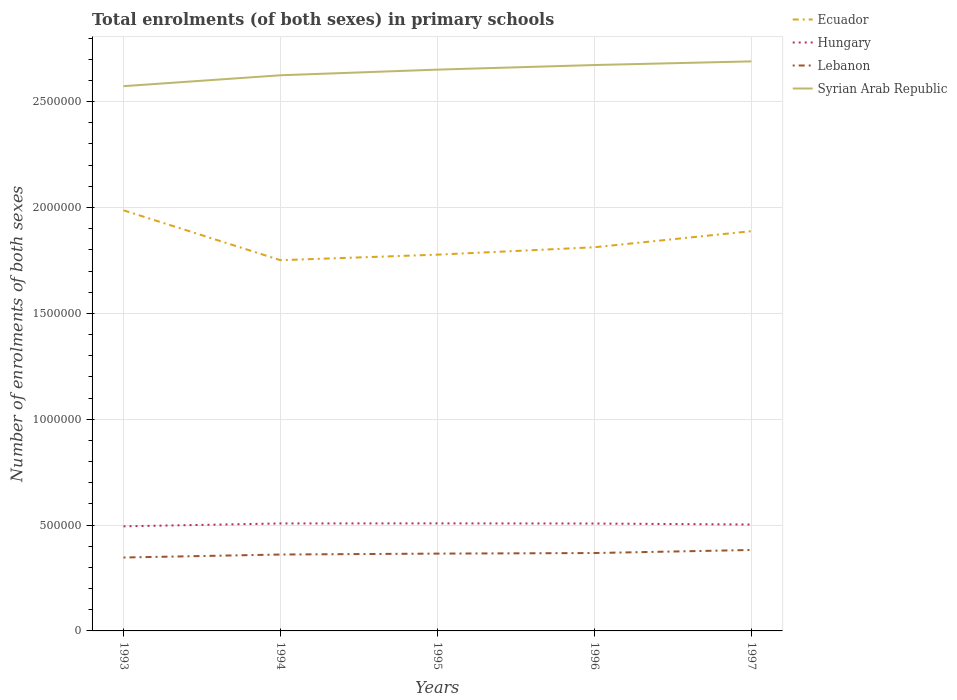How many different coloured lines are there?
Ensure brevity in your answer.  4. Across all years, what is the maximum number of enrolments in primary schools in Lebanon?
Provide a short and direct response. 3.47e+05. What is the total number of enrolments in primary schools in Lebanon in the graph?
Offer a very short reply. -1.41e+04. What is the difference between the highest and the second highest number of enrolments in primary schools in Syrian Arab Republic?
Offer a very short reply. 1.17e+05. How many lines are there?
Provide a short and direct response. 4. How many years are there in the graph?
Ensure brevity in your answer.  5. What is the difference between two consecutive major ticks on the Y-axis?
Your response must be concise. 5.00e+05. Are the values on the major ticks of Y-axis written in scientific E-notation?
Provide a short and direct response. No. Does the graph contain any zero values?
Ensure brevity in your answer.  No. Where does the legend appear in the graph?
Offer a very short reply. Top right. What is the title of the graph?
Provide a succinct answer. Total enrolments (of both sexes) in primary schools. What is the label or title of the Y-axis?
Keep it short and to the point. Number of enrolments of both sexes. What is the Number of enrolments of both sexes in Ecuador in 1993?
Your answer should be very brief. 1.99e+06. What is the Number of enrolments of both sexes in Hungary in 1993?
Your answer should be very brief. 4.94e+05. What is the Number of enrolments of both sexes in Lebanon in 1993?
Make the answer very short. 3.47e+05. What is the Number of enrolments of both sexes in Syrian Arab Republic in 1993?
Offer a very short reply. 2.57e+06. What is the Number of enrolments of both sexes in Ecuador in 1994?
Make the answer very short. 1.75e+06. What is the Number of enrolments of both sexes in Hungary in 1994?
Offer a very short reply. 5.08e+05. What is the Number of enrolments of both sexes in Lebanon in 1994?
Offer a terse response. 3.61e+05. What is the Number of enrolments of both sexes in Syrian Arab Republic in 1994?
Your answer should be compact. 2.62e+06. What is the Number of enrolments of both sexes in Ecuador in 1995?
Your response must be concise. 1.78e+06. What is the Number of enrolments of both sexes of Hungary in 1995?
Make the answer very short. 5.08e+05. What is the Number of enrolments of both sexes of Lebanon in 1995?
Keep it short and to the point. 3.65e+05. What is the Number of enrolments of both sexes of Syrian Arab Republic in 1995?
Offer a terse response. 2.65e+06. What is the Number of enrolments of both sexes of Ecuador in 1996?
Keep it short and to the point. 1.81e+06. What is the Number of enrolments of both sexes in Hungary in 1996?
Your answer should be compact. 5.07e+05. What is the Number of enrolments of both sexes in Lebanon in 1996?
Your response must be concise. 3.68e+05. What is the Number of enrolments of both sexes in Syrian Arab Republic in 1996?
Offer a terse response. 2.67e+06. What is the Number of enrolments of both sexes in Ecuador in 1997?
Offer a very short reply. 1.89e+06. What is the Number of enrolments of both sexes in Hungary in 1997?
Ensure brevity in your answer.  5.03e+05. What is the Number of enrolments of both sexes in Lebanon in 1997?
Keep it short and to the point. 3.82e+05. What is the Number of enrolments of both sexes in Syrian Arab Republic in 1997?
Ensure brevity in your answer.  2.69e+06. Across all years, what is the maximum Number of enrolments of both sexes in Ecuador?
Offer a very short reply. 1.99e+06. Across all years, what is the maximum Number of enrolments of both sexes in Hungary?
Offer a terse response. 5.08e+05. Across all years, what is the maximum Number of enrolments of both sexes of Lebanon?
Your response must be concise. 3.82e+05. Across all years, what is the maximum Number of enrolments of both sexes of Syrian Arab Republic?
Offer a very short reply. 2.69e+06. Across all years, what is the minimum Number of enrolments of both sexes of Ecuador?
Your answer should be very brief. 1.75e+06. Across all years, what is the minimum Number of enrolments of both sexes in Hungary?
Your response must be concise. 4.94e+05. Across all years, what is the minimum Number of enrolments of both sexes in Lebanon?
Your answer should be compact. 3.47e+05. Across all years, what is the minimum Number of enrolments of both sexes in Syrian Arab Republic?
Provide a succinct answer. 2.57e+06. What is the total Number of enrolments of both sexes of Ecuador in the graph?
Keep it short and to the point. 9.22e+06. What is the total Number of enrolments of both sexes of Hungary in the graph?
Give a very brief answer. 2.52e+06. What is the total Number of enrolments of both sexes of Lebanon in the graph?
Provide a short and direct response. 1.82e+06. What is the total Number of enrolments of both sexes in Syrian Arab Republic in the graph?
Make the answer very short. 1.32e+07. What is the difference between the Number of enrolments of both sexes of Ecuador in 1993 and that in 1994?
Make the answer very short. 2.36e+05. What is the difference between the Number of enrolments of both sexes of Hungary in 1993 and that in 1994?
Provide a succinct answer. -1.35e+04. What is the difference between the Number of enrolments of both sexes of Lebanon in 1993 and that in 1994?
Ensure brevity in your answer.  -1.41e+04. What is the difference between the Number of enrolments of both sexes in Syrian Arab Republic in 1993 and that in 1994?
Offer a terse response. -5.14e+04. What is the difference between the Number of enrolments of both sexes in Ecuador in 1993 and that in 1995?
Offer a very short reply. 2.09e+05. What is the difference between the Number of enrolments of both sexes of Hungary in 1993 and that in 1995?
Your answer should be very brief. -1.39e+04. What is the difference between the Number of enrolments of both sexes of Lebanon in 1993 and that in 1995?
Offer a terse response. -1.84e+04. What is the difference between the Number of enrolments of both sexes of Syrian Arab Republic in 1993 and that in 1995?
Provide a succinct answer. -7.81e+04. What is the difference between the Number of enrolments of both sexes of Ecuador in 1993 and that in 1996?
Provide a succinct answer. 1.74e+05. What is the difference between the Number of enrolments of both sexes of Hungary in 1993 and that in 1996?
Keep it short and to the point. -1.31e+04. What is the difference between the Number of enrolments of both sexes of Lebanon in 1993 and that in 1996?
Keep it short and to the point. -2.11e+04. What is the difference between the Number of enrolments of both sexes in Syrian Arab Republic in 1993 and that in 1996?
Make the answer very short. -9.98e+04. What is the difference between the Number of enrolments of both sexes in Ecuador in 1993 and that in 1997?
Keep it short and to the point. 9.86e+04. What is the difference between the Number of enrolments of both sexes in Hungary in 1993 and that in 1997?
Provide a succinct answer. -8448. What is the difference between the Number of enrolments of both sexes of Lebanon in 1993 and that in 1997?
Give a very brief answer. -3.55e+04. What is the difference between the Number of enrolments of both sexes in Syrian Arab Republic in 1993 and that in 1997?
Make the answer very short. -1.17e+05. What is the difference between the Number of enrolments of both sexes of Ecuador in 1994 and that in 1995?
Give a very brief answer. -2.62e+04. What is the difference between the Number of enrolments of both sexes in Hungary in 1994 and that in 1995?
Provide a succinct answer. -386. What is the difference between the Number of enrolments of both sexes in Lebanon in 1994 and that in 1995?
Make the answer very short. -4316. What is the difference between the Number of enrolments of both sexes of Syrian Arab Republic in 1994 and that in 1995?
Give a very brief answer. -2.67e+04. What is the difference between the Number of enrolments of both sexes of Ecuador in 1994 and that in 1996?
Your answer should be very brief. -6.11e+04. What is the difference between the Number of enrolments of both sexes in Hungary in 1994 and that in 1996?
Your response must be concise. 379. What is the difference between the Number of enrolments of both sexes in Lebanon in 1994 and that in 1996?
Offer a very short reply. -7004. What is the difference between the Number of enrolments of both sexes of Syrian Arab Republic in 1994 and that in 1996?
Ensure brevity in your answer.  -4.84e+04. What is the difference between the Number of enrolments of both sexes in Ecuador in 1994 and that in 1997?
Offer a very short reply. -1.37e+05. What is the difference between the Number of enrolments of both sexes in Hungary in 1994 and that in 1997?
Keep it short and to the point. 5062. What is the difference between the Number of enrolments of both sexes of Lebanon in 1994 and that in 1997?
Give a very brief answer. -2.15e+04. What is the difference between the Number of enrolments of both sexes of Syrian Arab Republic in 1994 and that in 1997?
Offer a terse response. -6.56e+04. What is the difference between the Number of enrolments of both sexes of Ecuador in 1995 and that in 1996?
Offer a very short reply. -3.50e+04. What is the difference between the Number of enrolments of both sexes in Hungary in 1995 and that in 1996?
Your response must be concise. 765. What is the difference between the Number of enrolments of both sexes in Lebanon in 1995 and that in 1996?
Offer a terse response. -2688. What is the difference between the Number of enrolments of both sexes of Syrian Arab Republic in 1995 and that in 1996?
Offer a terse response. -2.17e+04. What is the difference between the Number of enrolments of both sexes in Ecuador in 1995 and that in 1997?
Make the answer very short. -1.11e+05. What is the difference between the Number of enrolments of both sexes of Hungary in 1995 and that in 1997?
Your answer should be very brief. 5448. What is the difference between the Number of enrolments of both sexes in Lebanon in 1995 and that in 1997?
Make the answer very short. -1.71e+04. What is the difference between the Number of enrolments of both sexes in Syrian Arab Republic in 1995 and that in 1997?
Keep it short and to the point. -3.90e+04. What is the difference between the Number of enrolments of both sexes in Ecuador in 1996 and that in 1997?
Provide a succinct answer. -7.59e+04. What is the difference between the Number of enrolments of both sexes of Hungary in 1996 and that in 1997?
Ensure brevity in your answer.  4683. What is the difference between the Number of enrolments of both sexes of Lebanon in 1996 and that in 1997?
Offer a very short reply. -1.44e+04. What is the difference between the Number of enrolments of both sexes of Syrian Arab Republic in 1996 and that in 1997?
Your answer should be very brief. -1.72e+04. What is the difference between the Number of enrolments of both sexes of Ecuador in 1993 and the Number of enrolments of both sexes of Hungary in 1994?
Keep it short and to the point. 1.48e+06. What is the difference between the Number of enrolments of both sexes in Ecuador in 1993 and the Number of enrolments of both sexes in Lebanon in 1994?
Give a very brief answer. 1.63e+06. What is the difference between the Number of enrolments of both sexes of Ecuador in 1993 and the Number of enrolments of both sexes of Syrian Arab Republic in 1994?
Provide a succinct answer. -6.38e+05. What is the difference between the Number of enrolments of both sexes in Hungary in 1993 and the Number of enrolments of both sexes in Lebanon in 1994?
Your response must be concise. 1.33e+05. What is the difference between the Number of enrolments of both sexes of Hungary in 1993 and the Number of enrolments of both sexes of Syrian Arab Republic in 1994?
Provide a short and direct response. -2.13e+06. What is the difference between the Number of enrolments of both sexes in Lebanon in 1993 and the Number of enrolments of both sexes in Syrian Arab Republic in 1994?
Your answer should be very brief. -2.28e+06. What is the difference between the Number of enrolments of both sexes of Ecuador in 1993 and the Number of enrolments of both sexes of Hungary in 1995?
Offer a very short reply. 1.48e+06. What is the difference between the Number of enrolments of both sexes of Ecuador in 1993 and the Number of enrolments of both sexes of Lebanon in 1995?
Offer a very short reply. 1.62e+06. What is the difference between the Number of enrolments of both sexes of Ecuador in 1993 and the Number of enrolments of both sexes of Syrian Arab Republic in 1995?
Your response must be concise. -6.64e+05. What is the difference between the Number of enrolments of both sexes of Hungary in 1993 and the Number of enrolments of both sexes of Lebanon in 1995?
Provide a short and direct response. 1.29e+05. What is the difference between the Number of enrolments of both sexes of Hungary in 1993 and the Number of enrolments of both sexes of Syrian Arab Republic in 1995?
Your answer should be compact. -2.16e+06. What is the difference between the Number of enrolments of both sexes in Lebanon in 1993 and the Number of enrolments of both sexes in Syrian Arab Republic in 1995?
Give a very brief answer. -2.30e+06. What is the difference between the Number of enrolments of both sexes of Ecuador in 1993 and the Number of enrolments of both sexes of Hungary in 1996?
Make the answer very short. 1.48e+06. What is the difference between the Number of enrolments of both sexes of Ecuador in 1993 and the Number of enrolments of both sexes of Lebanon in 1996?
Provide a short and direct response. 1.62e+06. What is the difference between the Number of enrolments of both sexes of Ecuador in 1993 and the Number of enrolments of both sexes of Syrian Arab Republic in 1996?
Your answer should be compact. -6.86e+05. What is the difference between the Number of enrolments of both sexes in Hungary in 1993 and the Number of enrolments of both sexes in Lebanon in 1996?
Provide a succinct answer. 1.26e+05. What is the difference between the Number of enrolments of both sexes of Hungary in 1993 and the Number of enrolments of both sexes of Syrian Arab Republic in 1996?
Offer a terse response. -2.18e+06. What is the difference between the Number of enrolments of both sexes in Lebanon in 1993 and the Number of enrolments of both sexes in Syrian Arab Republic in 1996?
Your response must be concise. -2.33e+06. What is the difference between the Number of enrolments of both sexes in Ecuador in 1993 and the Number of enrolments of both sexes in Hungary in 1997?
Give a very brief answer. 1.48e+06. What is the difference between the Number of enrolments of both sexes of Ecuador in 1993 and the Number of enrolments of both sexes of Lebanon in 1997?
Provide a short and direct response. 1.60e+06. What is the difference between the Number of enrolments of both sexes of Ecuador in 1993 and the Number of enrolments of both sexes of Syrian Arab Republic in 1997?
Make the answer very short. -7.03e+05. What is the difference between the Number of enrolments of both sexes of Hungary in 1993 and the Number of enrolments of both sexes of Lebanon in 1997?
Offer a very short reply. 1.12e+05. What is the difference between the Number of enrolments of both sexes of Hungary in 1993 and the Number of enrolments of both sexes of Syrian Arab Republic in 1997?
Your response must be concise. -2.20e+06. What is the difference between the Number of enrolments of both sexes in Lebanon in 1993 and the Number of enrolments of both sexes in Syrian Arab Republic in 1997?
Your response must be concise. -2.34e+06. What is the difference between the Number of enrolments of both sexes in Ecuador in 1994 and the Number of enrolments of both sexes in Hungary in 1995?
Provide a succinct answer. 1.24e+06. What is the difference between the Number of enrolments of both sexes in Ecuador in 1994 and the Number of enrolments of both sexes in Lebanon in 1995?
Your answer should be very brief. 1.39e+06. What is the difference between the Number of enrolments of both sexes of Ecuador in 1994 and the Number of enrolments of both sexes of Syrian Arab Republic in 1995?
Make the answer very short. -9.00e+05. What is the difference between the Number of enrolments of both sexes of Hungary in 1994 and the Number of enrolments of both sexes of Lebanon in 1995?
Your answer should be compact. 1.42e+05. What is the difference between the Number of enrolments of both sexes of Hungary in 1994 and the Number of enrolments of both sexes of Syrian Arab Republic in 1995?
Offer a very short reply. -2.14e+06. What is the difference between the Number of enrolments of both sexes in Lebanon in 1994 and the Number of enrolments of both sexes in Syrian Arab Republic in 1995?
Offer a very short reply. -2.29e+06. What is the difference between the Number of enrolments of both sexes in Ecuador in 1994 and the Number of enrolments of both sexes in Hungary in 1996?
Offer a very short reply. 1.24e+06. What is the difference between the Number of enrolments of both sexes in Ecuador in 1994 and the Number of enrolments of both sexes in Lebanon in 1996?
Make the answer very short. 1.38e+06. What is the difference between the Number of enrolments of both sexes of Ecuador in 1994 and the Number of enrolments of both sexes of Syrian Arab Republic in 1996?
Your answer should be compact. -9.22e+05. What is the difference between the Number of enrolments of both sexes of Hungary in 1994 and the Number of enrolments of both sexes of Lebanon in 1996?
Your answer should be very brief. 1.40e+05. What is the difference between the Number of enrolments of both sexes in Hungary in 1994 and the Number of enrolments of both sexes in Syrian Arab Republic in 1996?
Provide a succinct answer. -2.17e+06. What is the difference between the Number of enrolments of both sexes in Lebanon in 1994 and the Number of enrolments of both sexes in Syrian Arab Republic in 1996?
Your response must be concise. -2.31e+06. What is the difference between the Number of enrolments of both sexes of Ecuador in 1994 and the Number of enrolments of both sexes of Hungary in 1997?
Provide a short and direct response. 1.25e+06. What is the difference between the Number of enrolments of both sexes in Ecuador in 1994 and the Number of enrolments of both sexes in Lebanon in 1997?
Your answer should be very brief. 1.37e+06. What is the difference between the Number of enrolments of both sexes of Ecuador in 1994 and the Number of enrolments of both sexes of Syrian Arab Republic in 1997?
Your answer should be compact. -9.39e+05. What is the difference between the Number of enrolments of both sexes in Hungary in 1994 and the Number of enrolments of both sexes in Lebanon in 1997?
Keep it short and to the point. 1.25e+05. What is the difference between the Number of enrolments of both sexes in Hungary in 1994 and the Number of enrolments of both sexes in Syrian Arab Republic in 1997?
Ensure brevity in your answer.  -2.18e+06. What is the difference between the Number of enrolments of both sexes of Lebanon in 1994 and the Number of enrolments of both sexes of Syrian Arab Republic in 1997?
Give a very brief answer. -2.33e+06. What is the difference between the Number of enrolments of both sexes in Ecuador in 1995 and the Number of enrolments of both sexes in Hungary in 1996?
Your response must be concise. 1.27e+06. What is the difference between the Number of enrolments of both sexes of Ecuador in 1995 and the Number of enrolments of both sexes of Lebanon in 1996?
Offer a terse response. 1.41e+06. What is the difference between the Number of enrolments of both sexes of Ecuador in 1995 and the Number of enrolments of both sexes of Syrian Arab Republic in 1996?
Your answer should be compact. -8.96e+05. What is the difference between the Number of enrolments of both sexes of Hungary in 1995 and the Number of enrolments of both sexes of Lebanon in 1996?
Offer a terse response. 1.40e+05. What is the difference between the Number of enrolments of both sexes of Hungary in 1995 and the Number of enrolments of both sexes of Syrian Arab Republic in 1996?
Your response must be concise. -2.16e+06. What is the difference between the Number of enrolments of both sexes of Lebanon in 1995 and the Number of enrolments of both sexes of Syrian Arab Republic in 1996?
Provide a short and direct response. -2.31e+06. What is the difference between the Number of enrolments of both sexes of Ecuador in 1995 and the Number of enrolments of both sexes of Hungary in 1997?
Provide a short and direct response. 1.27e+06. What is the difference between the Number of enrolments of both sexes in Ecuador in 1995 and the Number of enrolments of both sexes in Lebanon in 1997?
Give a very brief answer. 1.39e+06. What is the difference between the Number of enrolments of both sexes of Ecuador in 1995 and the Number of enrolments of both sexes of Syrian Arab Republic in 1997?
Give a very brief answer. -9.13e+05. What is the difference between the Number of enrolments of both sexes in Hungary in 1995 and the Number of enrolments of both sexes in Lebanon in 1997?
Your response must be concise. 1.26e+05. What is the difference between the Number of enrolments of both sexes of Hungary in 1995 and the Number of enrolments of both sexes of Syrian Arab Republic in 1997?
Provide a succinct answer. -2.18e+06. What is the difference between the Number of enrolments of both sexes of Lebanon in 1995 and the Number of enrolments of both sexes of Syrian Arab Republic in 1997?
Provide a succinct answer. -2.33e+06. What is the difference between the Number of enrolments of both sexes of Ecuador in 1996 and the Number of enrolments of both sexes of Hungary in 1997?
Your answer should be very brief. 1.31e+06. What is the difference between the Number of enrolments of both sexes of Ecuador in 1996 and the Number of enrolments of both sexes of Lebanon in 1997?
Make the answer very short. 1.43e+06. What is the difference between the Number of enrolments of both sexes of Ecuador in 1996 and the Number of enrolments of both sexes of Syrian Arab Republic in 1997?
Your answer should be compact. -8.78e+05. What is the difference between the Number of enrolments of both sexes in Hungary in 1996 and the Number of enrolments of both sexes in Lebanon in 1997?
Keep it short and to the point. 1.25e+05. What is the difference between the Number of enrolments of both sexes in Hungary in 1996 and the Number of enrolments of both sexes in Syrian Arab Republic in 1997?
Give a very brief answer. -2.18e+06. What is the difference between the Number of enrolments of both sexes of Lebanon in 1996 and the Number of enrolments of both sexes of Syrian Arab Republic in 1997?
Your answer should be compact. -2.32e+06. What is the average Number of enrolments of both sexes in Ecuador per year?
Provide a succinct answer. 1.84e+06. What is the average Number of enrolments of both sexes in Hungary per year?
Your answer should be very brief. 5.04e+05. What is the average Number of enrolments of both sexes in Lebanon per year?
Keep it short and to the point. 3.65e+05. What is the average Number of enrolments of both sexes of Syrian Arab Republic per year?
Your answer should be compact. 2.64e+06. In the year 1993, what is the difference between the Number of enrolments of both sexes in Ecuador and Number of enrolments of both sexes in Hungary?
Keep it short and to the point. 1.49e+06. In the year 1993, what is the difference between the Number of enrolments of both sexes of Ecuador and Number of enrolments of both sexes of Lebanon?
Provide a succinct answer. 1.64e+06. In the year 1993, what is the difference between the Number of enrolments of both sexes of Ecuador and Number of enrolments of both sexes of Syrian Arab Republic?
Make the answer very short. -5.86e+05. In the year 1993, what is the difference between the Number of enrolments of both sexes of Hungary and Number of enrolments of both sexes of Lebanon?
Your answer should be very brief. 1.47e+05. In the year 1993, what is the difference between the Number of enrolments of both sexes of Hungary and Number of enrolments of both sexes of Syrian Arab Republic?
Provide a short and direct response. -2.08e+06. In the year 1993, what is the difference between the Number of enrolments of both sexes in Lebanon and Number of enrolments of both sexes in Syrian Arab Republic?
Offer a very short reply. -2.23e+06. In the year 1994, what is the difference between the Number of enrolments of both sexes of Ecuador and Number of enrolments of both sexes of Hungary?
Provide a succinct answer. 1.24e+06. In the year 1994, what is the difference between the Number of enrolments of both sexes of Ecuador and Number of enrolments of both sexes of Lebanon?
Your answer should be compact. 1.39e+06. In the year 1994, what is the difference between the Number of enrolments of both sexes of Ecuador and Number of enrolments of both sexes of Syrian Arab Republic?
Make the answer very short. -8.73e+05. In the year 1994, what is the difference between the Number of enrolments of both sexes in Hungary and Number of enrolments of both sexes in Lebanon?
Your answer should be compact. 1.47e+05. In the year 1994, what is the difference between the Number of enrolments of both sexes in Hungary and Number of enrolments of both sexes in Syrian Arab Republic?
Provide a short and direct response. -2.12e+06. In the year 1994, what is the difference between the Number of enrolments of both sexes of Lebanon and Number of enrolments of both sexes of Syrian Arab Republic?
Provide a short and direct response. -2.26e+06. In the year 1995, what is the difference between the Number of enrolments of both sexes of Ecuador and Number of enrolments of both sexes of Hungary?
Your response must be concise. 1.27e+06. In the year 1995, what is the difference between the Number of enrolments of both sexes in Ecuador and Number of enrolments of both sexes in Lebanon?
Keep it short and to the point. 1.41e+06. In the year 1995, what is the difference between the Number of enrolments of both sexes of Ecuador and Number of enrolments of both sexes of Syrian Arab Republic?
Provide a short and direct response. -8.74e+05. In the year 1995, what is the difference between the Number of enrolments of both sexes in Hungary and Number of enrolments of both sexes in Lebanon?
Your answer should be very brief. 1.43e+05. In the year 1995, what is the difference between the Number of enrolments of both sexes of Hungary and Number of enrolments of both sexes of Syrian Arab Republic?
Keep it short and to the point. -2.14e+06. In the year 1995, what is the difference between the Number of enrolments of both sexes in Lebanon and Number of enrolments of both sexes in Syrian Arab Republic?
Your answer should be compact. -2.29e+06. In the year 1996, what is the difference between the Number of enrolments of both sexes in Ecuador and Number of enrolments of both sexes in Hungary?
Provide a succinct answer. 1.31e+06. In the year 1996, what is the difference between the Number of enrolments of both sexes in Ecuador and Number of enrolments of both sexes in Lebanon?
Give a very brief answer. 1.44e+06. In the year 1996, what is the difference between the Number of enrolments of both sexes in Ecuador and Number of enrolments of both sexes in Syrian Arab Republic?
Offer a terse response. -8.61e+05. In the year 1996, what is the difference between the Number of enrolments of both sexes in Hungary and Number of enrolments of both sexes in Lebanon?
Offer a very short reply. 1.39e+05. In the year 1996, what is the difference between the Number of enrolments of both sexes of Hungary and Number of enrolments of both sexes of Syrian Arab Republic?
Provide a succinct answer. -2.17e+06. In the year 1996, what is the difference between the Number of enrolments of both sexes of Lebanon and Number of enrolments of both sexes of Syrian Arab Republic?
Your answer should be very brief. -2.31e+06. In the year 1997, what is the difference between the Number of enrolments of both sexes of Ecuador and Number of enrolments of both sexes of Hungary?
Ensure brevity in your answer.  1.39e+06. In the year 1997, what is the difference between the Number of enrolments of both sexes in Ecuador and Number of enrolments of both sexes in Lebanon?
Provide a succinct answer. 1.51e+06. In the year 1997, what is the difference between the Number of enrolments of both sexes of Ecuador and Number of enrolments of both sexes of Syrian Arab Republic?
Ensure brevity in your answer.  -8.02e+05. In the year 1997, what is the difference between the Number of enrolments of both sexes of Hungary and Number of enrolments of both sexes of Lebanon?
Offer a very short reply. 1.20e+05. In the year 1997, what is the difference between the Number of enrolments of both sexes of Hungary and Number of enrolments of both sexes of Syrian Arab Republic?
Provide a short and direct response. -2.19e+06. In the year 1997, what is the difference between the Number of enrolments of both sexes in Lebanon and Number of enrolments of both sexes in Syrian Arab Republic?
Your response must be concise. -2.31e+06. What is the ratio of the Number of enrolments of both sexes of Ecuador in 1993 to that in 1994?
Offer a very short reply. 1.13. What is the ratio of the Number of enrolments of both sexes of Hungary in 1993 to that in 1994?
Your answer should be compact. 0.97. What is the ratio of the Number of enrolments of both sexes in Lebanon in 1993 to that in 1994?
Offer a terse response. 0.96. What is the ratio of the Number of enrolments of both sexes in Syrian Arab Republic in 1993 to that in 1994?
Keep it short and to the point. 0.98. What is the ratio of the Number of enrolments of both sexes in Ecuador in 1993 to that in 1995?
Your answer should be compact. 1.12. What is the ratio of the Number of enrolments of both sexes of Hungary in 1993 to that in 1995?
Offer a terse response. 0.97. What is the ratio of the Number of enrolments of both sexes of Lebanon in 1993 to that in 1995?
Ensure brevity in your answer.  0.95. What is the ratio of the Number of enrolments of both sexes in Syrian Arab Republic in 1993 to that in 1995?
Your answer should be compact. 0.97. What is the ratio of the Number of enrolments of both sexes of Ecuador in 1993 to that in 1996?
Provide a short and direct response. 1.1. What is the ratio of the Number of enrolments of both sexes in Hungary in 1993 to that in 1996?
Offer a terse response. 0.97. What is the ratio of the Number of enrolments of both sexes in Lebanon in 1993 to that in 1996?
Your answer should be very brief. 0.94. What is the ratio of the Number of enrolments of both sexes of Syrian Arab Republic in 1993 to that in 1996?
Offer a terse response. 0.96. What is the ratio of the Number of enrolments of both sexes in Ecuador in 1993 to that in 1997?
Offer a very short reply. 1.05. What is the ratio of the Number of enrolments of both sexes in Hungary in 1993 to that in 1997?
Your answer should be compact. 0.98. What is the ratio of the Number of enrolments of both sexes in Lebanon in 1993 to that in 1997?
Offer a very short reply. 0.91. What is the ratio of the Number of enrolments of both sexes of Syrian Arab Republic in 1993 to that in 1997?
Your response must be concise. 0.96. What is the ratio of the Number of enrolments of both sexes of Ecuador in 1994 to that in 1995?
Ensure brevity in your answer.  0.99. What is the ratio of the Number of enrolments of both sexes in Lebanon in 1994 to that in 1995?
Your answer should be very brief. 0.99. What is the ratio of the Number of enrolments of both sexes in Syrian Arab Republic in 1994 to that in 1995?
Your answer should be compact. 0.99. What is the ratio of the Number of enrolments of both sexes of Ecuador in 1994 to that in 1996?
Keep it short and to the point. 0.97. What is the ratio of the Number of enrolments of both sexes in Hungary in 1994 to that in 1996?
Your answer should be very brief. 1. What is the ratio of the Number of enrolments of both sexes of Lebanon in 1994 to that in 1996?
Give a very brief answer. 0.98. What is the ratio of the Number of enrolments of both sexes in Syrian Arab Republic in 1994 to that in 1996?
Keep it short and to the point. 0.98. What is the ratio of the Number of enrolments of both sexes in Ecuador in 1994 to that in 1997?
Provide a succinct answer. 0.93. What is the ratio of the Number of enrolments of both sexes of Hungary in 1994 to that in 1997?
Make the answer very short. 1.01. What is the ratio of the Number of enrolments of both sexes of Lebanon in 1994 to that in 1997?
Ensure brevity in your answer.  0.94. What is the ratio of the Number of enrolments of both sexes in Syrian Arab Republic in 1994 to that in 1997?
Keep it short and to the point. 0.98. What is the ratio of the Number of enrolments of both sexes in Ecuador in 1995 to that in 1996?
Keep it short and to the point. 0.98. What is the ratio of the Number of enrolments of both sexes in Hungary in 1995 to that in 1996?
Ensure brevity in your answer.  1. What is the ratio of the Number of enrolments of both sexes of Ecuador in 1995 to that in 1997?
Offer a terse response. 0.94. What is the ratio of the Number of enrolments of both sexes in Hungary in 1995 to that in 1997?
Provide a succinct answer. 1.01. What is the ratio of the Number of enrolments of both sexes of Lebanon in 1995 to that in 1997?
Make the answer very short. 0.96. What is the ratio of the Number of enrolments of both sexes of Syrian Arab Republic in 1995 to that in 1997?
Make the answer very short. 0.99. What is the ratio of the Number of enrolments of both sexes in Ecuador in 1996 to that in 1997?
Offer a very short reply. 0.96. What is the ratio of the Number of enrolments of both sexes in Hungary in 1996 to that in 1997?
Your answer should be compact. 1.01. What is the ratio of the Number of enrolments of both sexes of Lebanon in 1996 to that in 1997?
Offer a very short reply. 0.96. What is the difference between the highest and the second highest Number of enrolments of both sexes of Ecuador?
Provide a succinct answer. 9.86e+04. What is the difference between the highest and the second highest Number of enrolments of both sexes of Hungary?
Your response must be concise. 386. What is the difference between the highest and the second highest Number of enrolments of both sexes of Lebanon?
Make the answer very short. 1.44e+04. What is the difference between the highest and the second highest Number of enrolments of both sexes in Syrian Arab Republic?
Your response must be concise. 1.72e+04. What is the difference between the highest and the lowest Number of enrolments of both sexes in Ecuador?
Your answer should be very brief. 2.36e+05. What is the difference between the highest and the lowest Number of enrolments of both sexes of Hungary?
Keep it short and to the point. 1.39e+04. What is the difference between the highest and the lowest Number of enrolments of both sexes of Lebanon?
Ensure brevity in your answer.  3.55e+04. What is the difference between the highest and the lowest Number of enrolments of both sexes of Syrian Arab Republic?
Provide a succinct answer. 1.17e+05. 